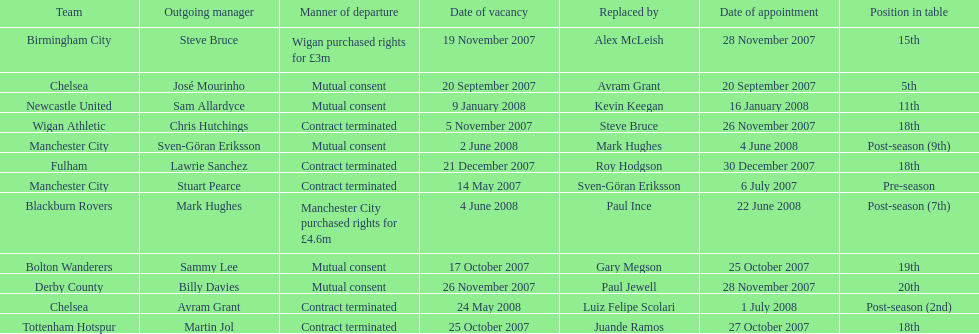Which outgoing manager was appointed the last? Mark Hughes. 